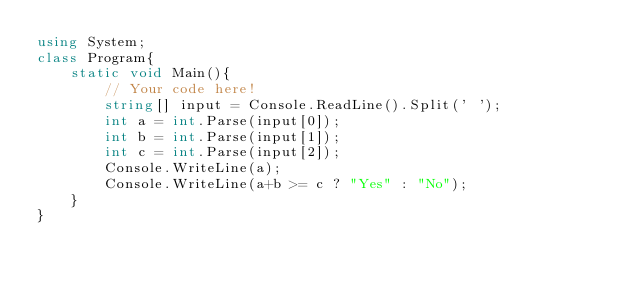Convert code to text. <code><loc_0><loc_0><loc_500><loc_500><_C#_>using System;
class Program{
    static void Main(){
        // Your code here!
        string[] input = Console.ReadLine().Split(' ');
        int a = int.Parse(input[0]);
        int b = int.Parse(input[1]);
        int c = int.Parse(input[2]);
        Console.WriteLine(a);
        Console.WriteLine(a+b >= c ? "Yes" : "No");
    }
}
</code> 